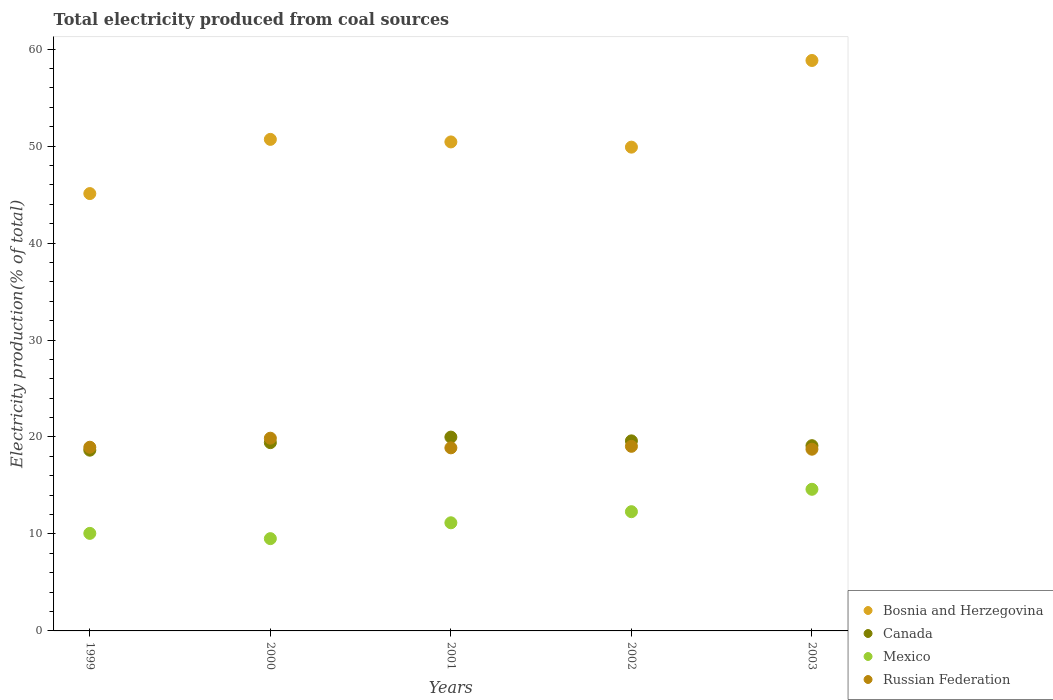What is the total electricity produced in Bosnia and Herzegovina in 2000?
Make the answer very short. 50.7. Across all years, what is the maximum total electricity produced in Canada?
Give a very brief answer. 19.99. Across all years, what is the minimum total electricity produced in Russian Federation?
Provide a succinct answer. 18.74. In which year was the total electricity produced in Canada maximum?
Give a very brief answer. 2001. In which year was the total electricity produced in Mexico minimum?
Offer a terse response. 2000. What is the total total electricity produced in Bosnia and Herzegovina in the graph?
Provide a succinct answer. 254.96. What is the difference between the total electricity produced in Canada in 2000 and that in 2002?
Give a very brief answer. -0.18. What is the difference between the total electricity produced in Bosnia and Herzegovina in 1999 and the total electricity produced in Russian Federation in 2001?
Make the answer very short. 26.22. What is the average total electricity produced in Russian Federation per year?
Ensure brevity in your answer.  19.1. In the year 2000, what is the difference between the total electricity produced in Canada and total electricity produced in Bosnia and Herzegovina?
Your answer should be very brief. -31.28. What is the ratio of the total electricity produced in Canada in 1999 to that in 2002?
Give a very brief answer. 0.95. Is the total electricity produced in Mexico in 1999 less than that in 2001?
Give a very brief answer. Yes. What is the difference between the highest and the second highest total electricity produced in Mexico?
Provide a succinct answer. 2.31. What is the difference between the highest and the lowest total electricity produced in Canada?
Give a very brief answer. 1.35. Is the sum of the total electricity produced in Canada in 1999 and 2002 greater than the maximum total electricity produced in Mexico across all years?
Give a very brief answer. Yes. Is it the case that in every year, the sum of the total electricity produced in Bosnia and Herzegovina and total electricity produced in Canada  is greater than the sum of total electricity produced in Mexico and total electricity produced in Russian Federation?
Provide a short and direct response. No. Is it the case that in every year, the sum of the total electricity produced in Mexico and total electricity produced in Bosnia and Herzegovina  is greater than the total electricity produced in Canada?
Make the answer very short. Yes. Does the total electricity produced in Russian Federation monotonically increase over the years?
Provide a short and direct response. No. Is the total electricity produced in Bosnia and Herzegovina strictly greater than the total electricity produced in Mexico over the years?
Provide a succinct answer. Yes. How many dotlines are there?
Your response must be concise. 4. How many years are there in the graph?
Your answer should be compact. 5. What is the difference between two consecutive major ticks on the Y-axis?
Provide a succinct answer. 10. Does the graph contain any zero values?
Give a very brief answer. No. Where does the legend appear in the graph?
Offer a very short reply. Bottom right. How many legend labels are there?
Keep it short and to the point. 4. How are the legend labels stacked?
Provide a short and direct response. Vertical. What is the title of the graph?
Provide a succinct answer. Total electricity produced from coal sources. Does "Benin" appear as one of the legend labels in the graph?
Your response must be concise. No. What is the label or title of the Y-axis?
Your answer should be very brief. Electricity production(% of total). What is the Electricity production(% of total) of Bosnia and Herzegovina in 1999?
Provide a short and direct response. 45.11. What is the Electricity production(% of total) in Canada in 1999?
Keep it short and to the point. 18.64. What is the Electricity production(% of total) of Mexico in 1999?
Provide a succinct answer. 10.06. What is the Electricity production(% of total) of Russian Federation in 1999?
Give a very brief answer. 18.94. What is the Electricity production(% of total) in Bosnia and Herzegovina in 2000?
Your answer should be very brief. 50.7. What is the Electricity production(% of total) in Canada in 2000?
Keep it short and to the point. 19.42. What is the Electricity production(% of total) of Mexico in 2000?
Your response must be concise. 9.52. What is the Electricity production(% of total) in Russian Federation in 2000?
Your answer should be compact. 19.88. What is the Electricity production(% of total) of Bosnia and Herzegovina in 2001?
Your answer should be very brief. 50.43. What is the Electricity production(% of total) of Canada in 2001?
Ensure brevity in your answer.  19.99. What is the Electricity production(% of total) of Mexico in 2001?
Make the answer very short. 11.15. What is the Electricity production(% of total) of Russian Federation in 2001?
Offer a terse response. 18.88. What is the Electricity production(% of total) of Bosnia and Herzegovina in 2002?
Provide a succinct answer. 49.89. What is the Electricity production(% of total) in Canada in 2002?
Provide a short and direct response. 19.6. What is the Electricity production(% of total) of Mexico in 2002?
Provide a short and direct response. 12.3. What is the Electricity production(% of total) of Russian Federation in 2002?
Your answer should be very brief. 19.04. What is the Electricity production(% of total) of Bosnia and Herzegovina in 2003?
Ensure brevity in your answer.  58.83. What is the Electricity production(% of total) of Canada in 2003?
Give a very brief answer. 19.11. What is the Electricity production(% of total) in Mexico in 2003?
Give a very brief answer. 14.61. What is the Electricity production(% of total) of Russian Federation in 2003?
Offer a terse response. 18.74. Across all years, what is the maximum Electricity production(% of total) of Bosnia and Herzegovina?
Offer a terse response. 58.83. Across all years, what is the maximum Electricity production(% of total) of Canada?
Provide a succinct answer. 19.99. Across all years, what is the maximum Electricity production(% of total) in Mexico?
Keep it short and to the point. 14.61. Across all years, what is the maximum Electricity production(% of total) in Russian Federation?
Ensure brevity in your answer.  19.88. Across all years, what is the minimum Electricity production(% of total) of Bosnia and Herzegovina?
Make the answer very short. 45.11. Across all years, what is the minimum Electricity production(% of total) in Canada?
Provide a succinct answer. 18.64. Across all years, what is the minimum Electricity production(% of total) in Mexico?
Your answer should be compact. 9.52. Across all years, what is the minimum Electricity production(% of total) in Russian Federation?
Ensure brevity in your answer.  18.74. What is the total Electricity production(% of total) of Bosnia and Herzegovina in the graph?
Offer a terse response. 254.96. What is the total Electricity production(% of total) of Canada in the graph?
Offer a very short reply. 96.75. What is the total Electricity production(% of total) in Mexico in the graph?
Your answer should be compact. 57.63. What is the total Electricity production(% of total) in Russian Federation in the graph?
Make the answer very short. 95.48. What is the difference between the Electricity production(% of total) of Bosnia and Herzegovina in 1999 and that in 2000?
Offer a very short reply. -5.59. What is the difference between the Electricity production(% of total) of Canada in 1999 and that in 2000?
Your answer should be very brief. -0.78. What is the difference between the Electricity production(% of total) of Mexico in 1999 and that in 2000?
Your answer should be very brief. 0.54. What is the difference between the Electricity production(% of total) in Russian Federation in 1999 and that in 2000?
Your response must be concise. -0.93. What is the difference between the Electricity production(% of total) of Bosnia and Herzegovina in 1999 and that in 2001?
Your answer should be compact. -5.33. What is the difference between the Electricity production(% of total) of Canada in 1999 and that in 2001?
Your response must be concise. -1.35. What is the difference between the Electricity production(% of total) in Mexico in 1999 and that in 2001?
Ensure brevity in your answer.  -1.09. What is the difference between the Electricity production(% of total) of Russian Federation in 1999 and that in 2001?
Your answer should be very brief. 0.06. What is the difference between the Electricity production(% of total) in Bosnia and Herzegovina in 1999 and that in 2002?
Offer a very short reply. -4.79. What is the difference between the Electricity production(% of total) of Canada in 1999 and that in 2002?
Offer a very short reply. -0.96. What is the difference between the Electricity production(% of total) in Mexico in 1999 and that in 2002?
Your answer should be very brief. -2.24. What is the difference between the Electricity production(% of total) in Russian Federation in 1999 and that in 2002?
Your answer should be compact. -0.09. What is the difference between the Electricity production(% of total) of Bosnia and Herzegovina in 1999 and that in 2003?
Offer a very short reply. -13.73. What is the difference between the Electricity production(% of total) of Canada in 1999 and that in 2003?
Make the answer very short. -0.46. What is the difference between the Electricity production(% of total) in Mexico in 1999 and that in 2003?
Make the answer very short. -4.55. What is the difference between the Electricity production(% of total) in Russian Federation in 1999 and that in 2003?
Your answer should be compact. 0.2. What is the difference between the Electricity production(% of total) of Bosnia and Herzegovina in 2000 and that in 2001?
Give a very brief answer. 0.26. What is the difference between the Electricity production(% of total) of Canada in 2000 and that in 2001?
Your answer should be very brief. -0.57. What is the difference between the Electricity production(% of total) of Mexico in 2000 and that in 2001?
Offer a very short reply. -1.64. What is the difference between the Electricity production(% of total) of Bosnia and Herzegovina in 2000 and that in 2002?
Keep it short and to the point. 0.8. What is the difference between the Electricity production(% of total) of Canada in 2000 and that in 2002?
Your answer should be compact. -0.18. What is the difference between the Electricity production(% of total) of Mexico in 2000 and that in 2002?
Make the answer very short. -2.78. What is the difference between the Electricity production(% of total) of Russian Federation in 2000 and that in 2002?
Offer a very short reply. 0.84. What is the difference between the Electricity production(% of total) of Bosnia and Herzegovina in 2000 and that in 2003?
Provide a short and direct response. -8.14. What is the difference between the Electricity production(% of total) of Canada in 2000 and that in 2003?
Your answer should be compact. 0.31. What is the difference between the Electricity production(% of total) in Mexico in 2000 and that in 2003?
Provide a succinct answer. -5.09. What is the difference between the Electricity production(% of total) of Russian Federation in 2000 and that in 2003?
Ensure brevity in your answer.  1.14. What is the difference between the Electricity production(% of total) of Bosnia and Herzegovina in 2001 and that in 2002?
Your answer should be very brief. 0.54. What is the difference between the Electricity production(% of total) in Canada in 2001 and that in 2002?
Your answer should be very brief. 0.39. What is the difference between the Electricity production(% of total) in Mexico in 2001 and that in 2002?
Make the answer very short. -1.14. What is the difference between the Electricity production(% of total) of Russian Federation in 2001 and that in 2002?
Your answer should be compact. -0.16. What is the difference between the Electricity production(% of total) in Bosnia and Herzegovina in 2001 and that in 2003?
Offer a terse response. -8.4. What is the difference between the Electricity production(% of total) in Canada in 2001 and that in 2003?
Offer a terse response. 0.88. What is the difference between the Electricity production(% of total) in Mexico in 2001 and that in 2003?
Give a very brief answer. -3.45. What is the difference between the Electricity production(% of total) of Russian Federation in 2001 and that in 2003?
Keep it short and to the point. 0.14. What is the difference between the Electricity production(% of total) in Bosnia and Herzegovina in 2002 and that in 2003?
Provide a short and direct response. -8.94. What is the difference between the Electricity production(% of total) in Canada in 2002 and that in 2003?
Offer a terse response. 0.5. What is the difference between the Electricity production(% of total) of Mexico in 2002 and that in 2003?
Keep it short and to the point. -2.31. What is the difference between the Electricity production(% of total) in Russian Federation in 2002 and that in 2003?
Offer a very short reply. 0.3. What is the difference between the Electricity production(% of total) in Bosnia and Herzegovina in 1999 and the Electricity production(% of total) in Canada in 2000?
Ensure brevity in your answer.  25.69. What is the difference between the Electricity production(% of total) of Bosnia and Herzegovina in 1999 and the Electricity production(% of total) of Mexico in 2000?
Keep it short and to the point. 35.59. What is the difference between the Electricity production(% of total) in Bosnia and Herzegovina in 1999 and the Electricity production(% of total) in Russian Federation in 2000?
Keep it short and to the point. 25.23. What is the difference between the Electricity production(% of total) in Canada in 1999 and the Electricity production(% of total) in Mexico in 2000?
Your response must be concise. 9.12. What is the difference between the Electricity production(% of total) of Canada in 1999 and the Electricity production(% of total) of Russian Federation in 2000?
Your response must be concise. -1.24. What is the difference between the Electricity production(% of total) in Mexico in 1999 and the Electricity production(% of total) in Russian Federation in 2000?
Offer a terse response. -9.82. What is the difference between the Electricity production(% of total) of Bosnia and Herzegovina in 1999 and the Electricity production(% of total) of Canada in 2001?
Your answer should be compact. 25.12. What is the difference between the Electricity production(% of total) in Bosnia and Herzegovina in 1999 and the Electricity production(% of total) in Mexico in 2001?
Keep it short and to the point. 33.95. What is the difference between the Electricity production(% of total) of Bosnia and Herzegovina in 1999 and the Electricity production(% of total) of Russian Federation in 2001?
Offer a terse response. 26.22. What is the difference between the Electricity production(% of total) in Canada in 1999 and the Electricity production(% of total) in Mexico in 2001?
Keep it short and to the point. 7.49. What is the difference between the Electricity production(% of total) in Canada in 1999 and the Electricity production(% of total) in Russian Federation in 2001?
Your answer should be very brief. -0.24. What is the difference between the Electricity production(% of total) in Mexico in 1999 and the Electricity production(% of total) in Russian Federation in 2001?
Your answer should be very brief. -8.82. What is the difference between the Electricity production(% of total) in Bosnia and Herzegovina in 1999 and the Electricity production(% of total) in Canada in 2002?
Your answer should be compact. 25.5. What is the difference between the Electricity production(% of total) of Bosnia and Herzegovina in 1999 and the Electricity production(% of total) of Mexico in 2002?
Provide a succinct answer. 32.81. What is the difference between the Electricity production(% of total) in Bosnia and Herzegovina in 1999 and the Electricity production(% of total) in Russian Federation in 2002?
Your answer should be compact. 26.07. What is the difference between the Electricity production(% of total) of Canada in 1999 and the Electricity production(% of total) of Mexico in 2002?
Offer a terse response. 6.34. What is the difference between the Electricity production(% of total) in Canada in 1999 and the Electricity production(% of total) in Russian Federation in 2002?
Make the answer very short. -0.4. What is the difference between the Electricity production(% of total) of Mexico in 1999 and the Electricity production(% of total) of Russian Federation in 2002?
Your response must be concise. -8.98. What is the difference between the Electricity production(% of total) of Bosnia and Herzegovina in 1999 and the Electricity production(% of total) of Canada in 2003?
Your response must be concise. 26. What is the difference between the Electricity production(% of total) of Bosnia and Herzegovina in 1999 and the Electricity production(% of total) of Mexico in 2003?
Offer a terse response. 30.5. What is the difference between the Electricity production(% of total) of Bosnia and Herzegovina in 1999 and the Electricity production(% of total) of Russian Federation in 2003?
Provide a succinct answer. 26.36. What is the difference between the Electricity production(% of total) of Canada in 1999 and the Electricity production(% of total) of Mexico in 2003?
Make the answer very short. 4.03. What is the difference between the Electricity production(% of total) in Canada in 1999 and the Electricity production(% of total) in Russian Federation in 2003?
Give a very brief answer. -0.1. What is the difference between the Electricity production(% of total) in Mexico in 1999 and the Electricity production(% of total) in Russian Federation in 2003?
Offer a terse response. -8.68. What is the difference between the Electricity production(% of total) in Bosnia and Herzegovina in 2000 and the Electricity production(% of total) in Canada in 2001?
Offer a very short reply. 30.71. What is the difference between the Electricity production(% of total) of Bosnia and Herzegovina in 2000 and the Electricity production(% of total) of Mexico in 2001?
Provide a short and direct response. 39.54. What is the difference between the Electricity production(% of total) of Bosnia and Herzegovina in 2000 and the Electricity production(% of total) of Russian Federation in 2001?
Offer a very short reply. 31.81. What is the difference between the Electricity production(% of total) in Canada in 2000 and the Electricity production(% of total) in Mexico in 2001?
Your answer should be very brief. 8.26. What is the difference between the Electricity production(% of total) in Canada in 2000 and the Electricity production(% of total) in Russian Federation in 2001?
Your answer should be very brief. 0.53. What is the difference between the Electricity production(% of total) of Mexico in 2000 and the Electricity production(% of total) of Russian Federation in 2001?
Provide a succinct answer. -9.36. What is the difference between the Electricity production(% of total) in Bosnia and Herzegovina in 2000 and the Electricity production(% of total) in Canada in 2002?
Your answer should be very brief. 31.09. What is the difference between the Electricity production(% of total) of Bosnia and Herzegovina in 2000 and the Electricity production(% of total) of Mexico in 2002?
Offer a very short reply. 38.4. What is the difference between the Electricity production(% of total) of Bosnia and Herzegovina in 2000 and the Electricity production(% of total) of Russian Federation in 2002?
Make the answer very short. 31.66. What is the difference between the Electricity production(% of total) of Canada in 2000 and the Electricity production(% of total) of Mexico in 2002?
Make the answer very short. 7.12. What is the difference between the Electricity production(% of total) in Canada in 2000 and the Electricity production(% of total) in Russian Federation in 2002?
Provide a succinct answer. 0.38. What is the difference between the Electricity production(% of total) of Mexico in 2000 and the Electricity production(% of total) of Russian Federation in 2002?
Provide a succinct answer. -9.52. What is the difference between the Electricity production(% of total) of Bosnia and Herzegovina in 2000 and the Electricity production(% of total) of Canada in 2003?
Make the answer very short. 31.59. What is the difference between the Electricity production(% of total) of Bosnia and Herzegovina in 2000 and the Electricity production(% of total) of Mexico in 2003?
Give a very brief answer. 36.09. What is the difference between the Electricity production(% of total) in Bosnia and Herzegovina in 2000 and the Electricity production(% of total) in Russian Federation in 2003?
Your response must be concise. 31.95. What is the difference between the Electricity production(% of total) of Canada in 2000 and the Electricity production(% of total) of Mexico in 2003?
Make the answer very short. 4.81. What is the difference between the Electricity production(% of total) in Canada in 2000 and the Electricity production(% of total) in Russian Federation in 2003?
Your answer should be very brief. 0.68. What is the difference between the Electricity production(% of total) in Mexico in 2000 and the Electricity production(% of total) in Russian Federation in 2003?
Give a very brief answer. -9.22. What is the difference between the Electricity production(% of total) in Bosnia and Herzegovina in 2001 and the Electricity production(% of total) in Canada in 2002?
Keep it short and to the point. 30.83. What is the difference between the Electricity production(% of total) in Bosnia and Herzegovina in 2001 and the Electricity production(% of total) in Mexico in 2002?
Offer a very short reply. 38.14. What is the difference between the Electricity production(% of total) in Bosnia and Herzegovina in 2001 and the Electricity production(% of total) in Russian Federation in 2002?
Provide a succinct answer. 31.39. What is the difference between the Electricity production(% of total) in Canada in 2001 and the Electricity production(% of total) in Mexico in 2002?
Your response must be concise. 7.69. What is the difference between the Electricity production(% of total) in Canada in 2001 and the Electricity production(% of total) in Russian Federation in 2002?
Your response must be concise. 0.95. What is the difference between the Electricity production(% of total) in Mexico in 2001 and the Electricity production(% of total) in Russian Federation in 2002?
Provide a short and direct response. -7.89. What is the difference between the Electricity production(% of total) of Bosnia and Herzegovina in 2001 and the Electricity production(% of total) of Canada in 2003?
Make the answer very short. 31.33. What is the difference between the Electricity production(% of total) in Bosnia and Herzegovina in 2001 and the Electricity production(% of total) in Mexico in 2003?
Ensure brevity in your answer.  35.83. What is the difference between the Electricity production(% of total) in Bosnia and Herzegovina in 2001 and the Electricity production(% of total) in Russian Federation in 2003?
Ensure brevity in your answer.  31.69. What is the difference between the Electricity production(% of total) in Canada in 2001 and the Electricity production(% of total) in Mexico in 2003?
Offer a very short reply. 5.38. What is the difference between the Electricity production(% of total) in Canada in 2001 and the Electricity production(% of total) in Russian Federation in 2003?
Your answer should be compact. 1.25. What is the difference between the Electricity production(% of total) in Mexico in 2001 and the Electricity production(% of total) in Russian Federation in 2003?
Keep it short and to the point. -7.59. What is the difference between the Electricity production(% of total) of Bosnia and Herzegovina in 2002 and the Electricity production(% of total) of Canada in 2003?
Provide a short and direct response. 30.79. What is the difference between the Electricity production(% of total) in Bosnia and Herzegovina in 2002 and the Electricity production(% of total) in Mexico in 2003?
Offer a terse response. 35.29. What is the difference between the Electricity production(% of total) in Bosnia and Herzegovina in 2002 and the Electricity production(% of total) in Russian Federation in 2003?
Give a very brief answer. 31.15. What is the difference between the Electricity production(% of total) of Canada in 2002 and the Electricity production(% of total) of Mexico in 2003?
Ensure brevity in your answer.  5. What is the difference between the Electricity production(% of total) of Canada in 2002 and the Electricity production(% of total) of Russian Federation in 2003?
Your answer should be very brief. 0.86. What is the difference between the Electricity production(% of total) in Mexico in 2002 and the Electricity production(% of total) in Russian Federation in 2003?
Make the answer very short. -6.44. What is the average Electricity production(% of total) in Bosnia and Herzegovina per year?
Offer a terse response. 50.99. What is the average Electricity production(% of total) in Canada per year?
Your answer should be compact. 19.35. What is the average Electricity production(% of total) of Mexico per year?
Provide a succinct answer. 11.53. What is the average Electricity production(% of total) in Russian Federation per year?
Your response must be concise. 19.1. In the year 1999, what is the difference between the Electricity production(% of total) of Bosnia and Herzegovina and Electricity production(% of total) of Canada?
Keep it short and to the point. 26.46. In the year 1999, what is the difference between the Electricity production(% of total) of Bosnia and Herzegovina and Electricity production(% of total) of Mexico?
Your response must be concise. 35.05. In the year 1999, what is the difference between the Electricity production(% of total) in Bosnia and Herzegovina and Electricity production(% of total) in Russian Federation?
Provide a short and direct response. 26.16. In the year 1999, what is the difference between the Electricity production(% of total) of Canada and Electricity production(% of total) of Mexico?
Provide a succinct answer. 8.58. In the year 1999, what is the difference between the Electricity production(% of total) in Canada and Electricity production(% of total) in Russian Federation?
Offer a terse response. -0.3. In the year 1999, what is the difference between the Electricity production(% of total) in Mexico and Electricity production(% of total) in Russian Federation?
Offer a terse response. -8.88. In the year 2000, what is the difference between the Electricity production(% of total) in Bosnia and Herzegovina and Electricity production(% of total) in Canada?
Make the answer very short. 31.28. In the year 2000, what is the difference between the Electricity production(% of total) of Bosnia and Herzegovina and Electricity production(% of total) of Mexico?
Give a very brief answer. 41.18. In the year 2000, what is the difference between the Electricity production(% of total) of Bosnia and Herzegovina and Electricity production(% of total) of Russian Federation?
Ensure brevity in your answer.  30.82. In the year 2000, what is the difference between the Electricity production(% of total) in Canada and Electricity production(% of total) in Mexico?
Ensure brevity in your answer.  9.9. In the year 2000, what is the difference between the Electricity production(% of total) in Canada and Electricity production(% of total) in Russian Federation?
Provide a succinct answer. -0.46. In the year 2000, what is the difference between the Electricity production(% of total) of Mexico and Electricity production(% of total) of Russian Federation?
Your response must be concise. -10.36. In the year 2001, what is the difference between the Electricity production(% of total) of Bosnia and Herzegovina and Electricity production(% of total) of Canada?
Your answer should be very brief. 30.44. In the year 2001, what is the difference between the Electricity production(% of total) in Bosnia and Herzegovina and Electricity production(% of total) in Mexico?
Your answer should be compact. 39.28. In the year 2001, what is the difference between the Electricity production(% of total) of Bosnia and Herzegovina and Electricity production(% of total) of Russian Federation?
Your answer should be compact. 31.55. In the year 2001, what is the difference between the Electricity production(% of total) in Canada and Electricity production(% of total) in Mexico?
Provide a short and direct response. 8.84. In the year 2001, what is the difference between the Electricity production(% of total) in Canada and Electricity production(% of total) in Russian Federation?
Make the answer very short. 1.11. In the year 2001, what is the difference between the Electricity production(% of total) in Mexico and Electricity production(% of total) in Russian Federation?
Your answer should be compact. -7.73. In the year 2002, what is the difference between the Electricity production(% of total) in Bosnia and Herzegovina and Electricity production(% of total) in Canada?
Ensure brevity in your answer.  30.29. In the year 2002, what is the difference between the Electricity production(% of total) in Bosnia and Herzegovina and Electricity production(% of total) in Mexico?
Your response must be concise. 37.6. In the year 2002, what is the difference between the Electricity production(% of total) of Bosnia and Herzegovina and Electricity production(% of total) of Russian Federation?
Keep it short and to the point. 30.85. In the year 2002, what is the difference between the Electricity production(% of total) of Canada and Electricity production(% of total) of Mexico?
Keep it short and to the point. 7.3. In the year 2002, what is the difference between the Electricity production(% of total) in Canada and Electricity production(% of total) in Russian Federation?
Keep it short and to the point. 0.56. In the year 2002, what is the difference between the Electricity production(% of total) of Mexico and Electricity production(% of total) of Russian Federation?
Your answer should be compact. -6.74. In the year 2003, what is the difference between the Electricity production(% of total) of Bosnia and Herzegovina and Electricity production(% of total) of Canada?
Provide a succinct answer. 39.73. In the year 2003, what is the difference between the Electricity production(% of total) in Bosnia and Herzegovina and Electricity production(% of total) in Mexico?
Make the answer very short. 44.23. In the year 2003, what is the difference between the Electricity production(% of total) of Bosnia and Herzegovina and Electricity production(% of total) of Russian Federation?
Your answer should be very brief. 40.09. In the year 2003, what is the difference between the Electricity production(% of total) of Canada and Electricity production(% of total) of Mexico?
Provide a short and direct response. 4.5. In the year 2003, what is the difference between the Electricity production(% of total) of Canada and Electricity production(% of total) of Russian Federation?
Provide a short and direct response. 0.36. In the year 2003, what is the difference between the Electricity production(% of total) in Mexico and Electricity production(% of total) in Russian Federation?
Provide a short and direct response. -4.13. What is the ratio of the Electricity production(% of total) in Bosnia and Herzegovina in 1999 to that in 2000?
Give a very brief answer. 0.89. What is the ratio of the Electricity production(% of total) of Canada in 1999 to that in 2000?
Make the answer very short. 0.96. What is the ratio of the Electricity production(% of total) in Mexico in 1999 to that in 2000?
Your answer should be compact. 1.06. What is the ratio of the Electricity production(% of total) of Russian Federation in 1999 to that in 2000?
Your answer should be compact. 0.95. What is the ratio of the Electricity production(% of total) in Bosnia and Herzegovina in 1999 to that in 2001?
Ensure brevity in your answer.  0.89. What is the ratio of the Electricity production(% of total) in Canada in 1999 to that in 2001?
Your answer should be compact. 0.93. What is the ratio of the Electricity production(% of total) of Mexico in 1999 to that in 2001?
Keep it short and to the point. 0.9. What is the ratio of the Electricity production(% of total) in Bosnia and Herzegovina in 1999 to that in 2002?
Provide a succinct answer. 0.9. What is the ratio of the Electricity production(% of total) in Canada in 1999 to that in 2002?
Make the answer very short. 0.95. What is the ratio of the Electricity production(% of total) of Mexico in 1999 to that in 2002?
Your response must be concise. 0.82. What is the ratio of the Electricity production(% of total) in Bosnia and Herzegovina in 1999 to that in 2003?
Provide a succinct answer. 0.77. What is the ratio of the Electricity production(% of total) of Canada in 1999 to that in 2003?
Give a very brief answer. 0.98. What is the ratio of the Electricity production(% of total) in Mexico in 1999 to that in 2003?
Offer a very short reply. 0.69. What is the ratio of the Electricity production(% of total) in Russian Federation in 1999 to that in 2003?
Make the answer very short. 1.01. What is the ratio of the Electricity production(% of total) of Canada in 2000 to that in 2001?
Keep it short and to the point. 0.97. What is the ratio of the Electricity production(% of total) in Mexico in 2000 to that in 2001?
Provide a short and direct response. 0.85. What is the ratio of the Electricity production(% of total) of Russian Federation in 2000 to that in 2001?
Provide a short and direct response. 1.05. What is the ratio of the Electricity production(% of total) of Bosnia and Herzegovina in 2000 to that in 2002?
Ensure brevity in your answer.  1.02. What is the ratio of the Electricity production(% of total) in Canada in 2000 to that in 2002?
Your answer should be very brief. 0.99. What is the ratio of the Electricity production(% of total) in Mexico in 2000 to that in 2002?
Offer a terse response. 0.77. What is the ratio of the Electricity production(% of total) of Russian Federation in 2000 to that in 2002?
Make the answer very short. 1.04. What is the ratio of the Electricity production(% of total) in Bosnia and Herzegovina in 2000 to that in 2003?
Offer a very short reply. 0.86. What is the ratio of the Electricity production(% of total) in Canada in 2000 to that in 2003?
Your answer should be compact. 1.02. What is the ratio of the Electricity production(% of total) in Mexico in 2000 to that in 2003?
Give a very brief answer. 0.65. What is the ratio of the Electricity production(% of total) in Russian Federation in 2000 to that in 2003?
Make the answer very short. 1.06. What is the ratio of the Electricity production(% of total) of Bosnia and Herzegovina in 2001 to that in 2002?
Ensure brevity in your answer.  1.01. What is the ratio of the Electricity production(% of total) in Canada in 2001 to that in 2002?
Offer a very short reply. 1.02. What is the ratio of the Electricity production(% of total) in Mexico in 2001 to that in 2002?
Ensure brevity in your answer.  0.91. What is the ratio of the Electricity production(% of total) of Bosnia and Herzegovina in 2001 to that in 2003?
Ensure brevity in your answer.  0.86. What is the ratio of the Electricity production(% of total) in Canada in 2001 to that in 2003?
Offer a very short reply. 1.05. What is the ratio of the Electricity production(% of total) of Mexico in 2001 to that in 2003?
Provide a succinct answer. 0.76. What is the ratio of the Electricity production(% of total) in Russian Federation in 2001 to that in 2003?
Your answer should be very brief. 1.01. What is the ratio of the Electricity production(% of total) of Bosnia and Herzegovina in 2002 to that in 2003?
Give a very brief answer. 0.85. What is the ratio of the Electricity production(% of total) in Mexico in 2002 to that in 2003?
Make the answer very short. 0.84. What is the ratio of the Electricity production(% of total) in Russian Federation in 2002 to that in 2003?
Offer a terse response. 1.02. What is the difference between the highest and the second highest Electricity production(% of total) of Bosnia and Herzegovina?
Your answer should be compact. 8.14. What is the difference between the highest and the second highest Electricity production(% of total) in Canada?
Your answer should be compact. 0.39. What is the difference between the highest and the second highest Electricity production(% of total) in Mexico?
Your answer should be compact. 2.31. What is the difference between the highest and the second highest Electricity production(% of total) in Russian Federation?
Your answer should be very brief. 0.84. What is the difference between the highest and the lowest Electricity production(% of total) in Bosnia and Herzegovina?
Make the answer very short. 13.73. What is the difference between the highest and the lowest Electricity production(% of total) of Canada?
Offer a very short reply. 1.35. What is the difference between the highest and the lowest Electricity production(% of total) of Mexico?
Provide a succinct answer. 5.09. What is the difference between the highest and the lowest Electricity production(% of total) of Russian Federation?
Make the answer very short. 1.14. 